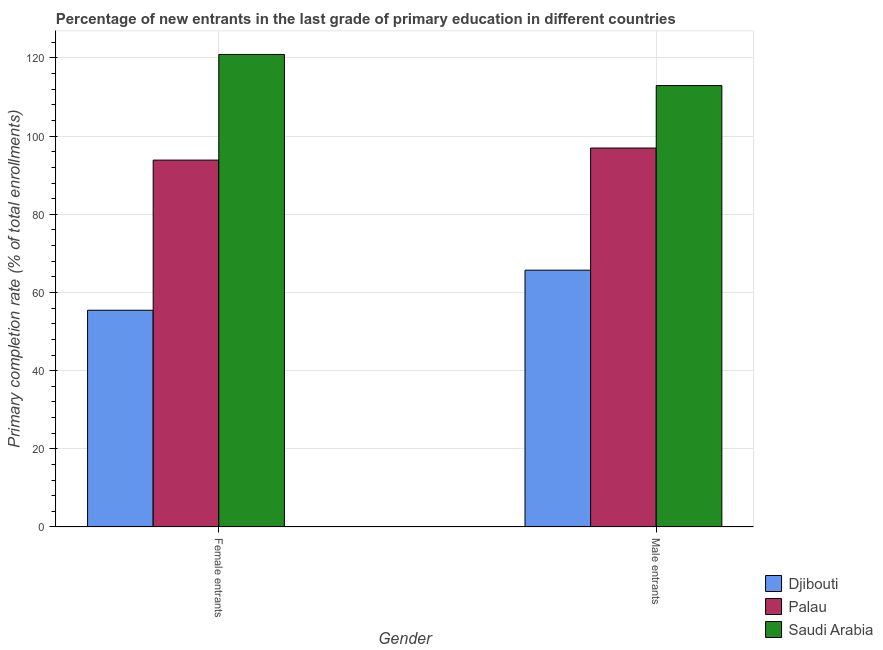How many different coloured bars are there?
Provide a succinct answer. 3. How many groups of bars are there?
Offer a terse response. 2. Are the number of bars per tick equal to the number of legend labels?
Offer a terse response. Yes. Are the number of bars on each tick of the X-axis equal?
Provide a succinct answer. Yes. What is the label of the 1st group of bars from the left?
Provide a short and direct response. Female entrants. What is the primary completion rate of female entrants in Palau?
Provide a succinct answer. 93.86. Across all countries, what is the maximum primary completion rate of female entrants?
Your answer should be compact. 120.89. Across all countries, what is the minimum primary completion rate of female entrants?
Your response must be concise. 55.45. In which country was the primary completion rate of male entrants maximum?
Your response must be concise. Saudi Arabia. In which country was the primary completion rate of male entrants minimum?
Offer a very short reply. Djibouti. What is the total primary completion rate of male entrants in the graph?
Provide a succinct answer. 275.57. What is the difference between the primary completion rate of female entrants in Saudi Arabia and that in Palau?
Your answer should be compact. 27.03. What is the difference between the primary completion rate of female entrants in Saudi Arabia and the primary completion rate of male entrants in Palau?
Make the answer very short. 23.94. What is the average primary completion rate of female entrants per country?
Give a very brief answer. 90.07. What is the difference between the primary completion rate of male entrants and primary completion rate of female entrants in Palau?
Ensure brevity in your answer.  3.09. In how many countries, is the primary completion rate of female entrants greater than 116 %?
Your answer should be compact. 1. What is the ratio of the primary completion rate of female entrants in Djibouti to that in Palau?
Offer a very short reply. 0.59. Is the primary completion rate of female entrants in Saudi Arabia less than that in Palau?
Provide a short and direct response. No. In how many countries, is the primary completion rate of male entrants greater than the average primary completion rate of male entrants taken over all countries?
Give a very brief answer. 2. What does the 1st bar from the left in Female entrants represents?
Your answer should be very brief. Djibouti. What does the 2nd bar from the right in Male entrants represents?
Your answer should be compact. Palau. How many legend labels are there?
Your answer should be compact. 3. How are the legend labels stacked?
Provide a succinct answer. Vertical. What is the title of the graph?
Offer a terse response. Percentage of new entrants in the last grade of primary education in different countries. What is the label or title of the Y-axis?
Provide a succinct answer. Primary completion rate (% of total enrollments). What is the Primary completion rate (% of total enrollments) of Djibouti in Female entrants?
Ensure brevity in your answer.  55.45. What is the Primary completion rate (% of total enrollments) in Palau in Female entrants?
Your response must be concise. 93.86. What is the Primary completion rate (% of total enrollments) in Saudi Arabia in Female entrants?
Provide a short and direct response. 120.89. What is the Primary completion rate (% of total enrollments) in Djibouti in Male entrants?
Keep it short and to the point. 65.7. What is the Primary completion rate (% of total enrollments) of Palau in Male entrants?
Ensure brevity in your answer.  96.95. What is the Primary completion rate (% of total enrollments) in Saudi Arabia in Male entrants?
Keep it short and to the point. 112.93. Across all Gender, what is the maximum Primary completion rate (% of total enrollments) of Djibouti?
Offer a terse response. 65.7. Across all Gender, what is the maximum Primary completion rate (% of total enrollments) in Palau?
Your answer should be very brief. 96.95. Across all Gender, what is the maximum Primary completion rate (% of total enrollments) in Saudi Arabia?
Make the answer very short. 120.89. Across all Gender, what is the minimum Primary completion rate (% of total enrollments) in Djibouti?
Your response must be concise. 55.45. Across all Gender, what is the minimum Primary completion rate (% of total enrollments) in Palau?
Offer a terse response. 93.86. Across all Gender, what is the minimum Primary completion rate (% of total enrollments) of Saudi Arabia?
Keep it short and to the point. 112.93. What is the total Primary completion rate (% of total enrollments) in Djibouti in the graph?
Offer a very short reply. 121.15. What is the total Primary completion rate (% of total enrollments) of Palau in the graph?
Offer a very short reply. 190.81. What is the total Primary completion rate (% of total enrollments) of Saudi Arabia in the graph?
Your answer should be very brief. 233.82. What is the difference between the Primary completion rate (% of total enrollments) in Djibouti in Female entrants and that in Male entrants?
Your answer should be compact. -10.25. What is the difference between the Primary completion rate (% of total enrollments) in Palau in Female entrants and that in Male entrants?
Provide a succinct answer. -3.09. What is the difference between the Primary completion rate (% of total enrollments) in Saudi Arabia in Female entrants and that in Male entrants?
Ensure brevity in your answer.  7.96. What is the difference between the Primary completion rate (% of total enrollments) of Djibouti in Female entrants and the Primary completion rate (% of total enrollments) of Palau in Male entrants?
Provide a short and direct response. -41.5. What is the difference between the Primary completion rate (% of total enrollments) of Djibouti in Female entrants and the Primary completion rate (% of total enrollments) of Saudi Arabia in Male entrants?
Make the answer very short. -57.48. What is the difference between the Primary completion rate (% of total enrollments) in Palau in Female entrants and the Primary completion rate (% of total enrollments) in Saudi Arabia in Male entrants?
Your response must be concise. -19.07. What is the average Primary completion rate (% of total enrollments) in Djibouti per Gender?
Provide a succinct answer. 60.58. What is the average Primary completion rate (% of total enrollments) of Palau per Gender?
Your answer should be compact. 95.4. What is the average Primary completion rate (% of total enrollments) in Saudi Arabia per Gender?
Ensure brevity in your answer.  116.91. What is the difference between the Primary completion rate (% of total enrollments) in Djibouti and Primary completion rate (% of total enrollments) in Palau in Female entrants?
Keep it short and to the point. -38.41. What is the difference between the Primary completion rate (% of total enrollments) in Djibouti and Primary completion rate (% of total enrollments) in Saudi Arabia in Female entrants?
Your answer should be very brief. -65.44. What is the difference between the Primary completion rate (% of total enrollments) of Palau and Primary completion rate (% of total enrollments) of Saudi Arabia in Female entrants?
Your response must be concise. -27.03. What is the difference between the Primary completion rate (% of total enrollments) of Djibouti and Primary completion rate (% of total enrollments) of Palau in Male entrants?
Offer a very short reply. -31.25. What is the difference between the Primary completion rate (% of total enrollments) in Djibouti and Primary completion rate (% of total enrollments) in Saudi Arabia in Male entrants?
Your answer should be very brief. -47.23. What is the difference between the Primary completion rate (% of total enrollments) of Palau and Primary completion rate (% of total enrollments) of Saudi Arabia in Male entrants?
Make the answer very short. -15.98. What is the ratio of the Primary completion rate (% of total enrollments) of Djibouti in Female entrants to that in Male entrants?
Provide a succinct answer. 0.84. What is the ratio of the Primary completion rate (% of total enrollments) in Palau in Female entrants to that in Male entrants?
Provide a succinct answer. 0.97. What is the ratio of the Primary completion rate (% of total enrollments) in Saudi Arabia in Female entrants to that in Male entrants?
Provide a succinct answer. 1.07. What is the difference between the highest and the second highest Primary completion rate (% of total enrollments) in Djibouti?
Offer a very short reply. 10.25. What is the difference between the highest and the second highest Primary completion rate (% of total enrollments) in Palau?
Your response must be concise. 3.09. What is the difference between the highest and the second highest Primary completion rate (% of total enrollments) in Saudi Arabia?
Your answer should be very brief. 7.96. What is the difference between the highest and the lowest Primary completion rate (% of total enrollments) in Djibouti?
Make the answer very short. 10.25. What is the difference between the highest and the lowest Primary completion rate (% of total enrollments) of Palau?
Keep it short and to the point. 3.09. What is the difference between the highest and the lowest Primary completion rate (% of total enrollments) in Saudi Arabia?
Make the answer very short. 7.96. 